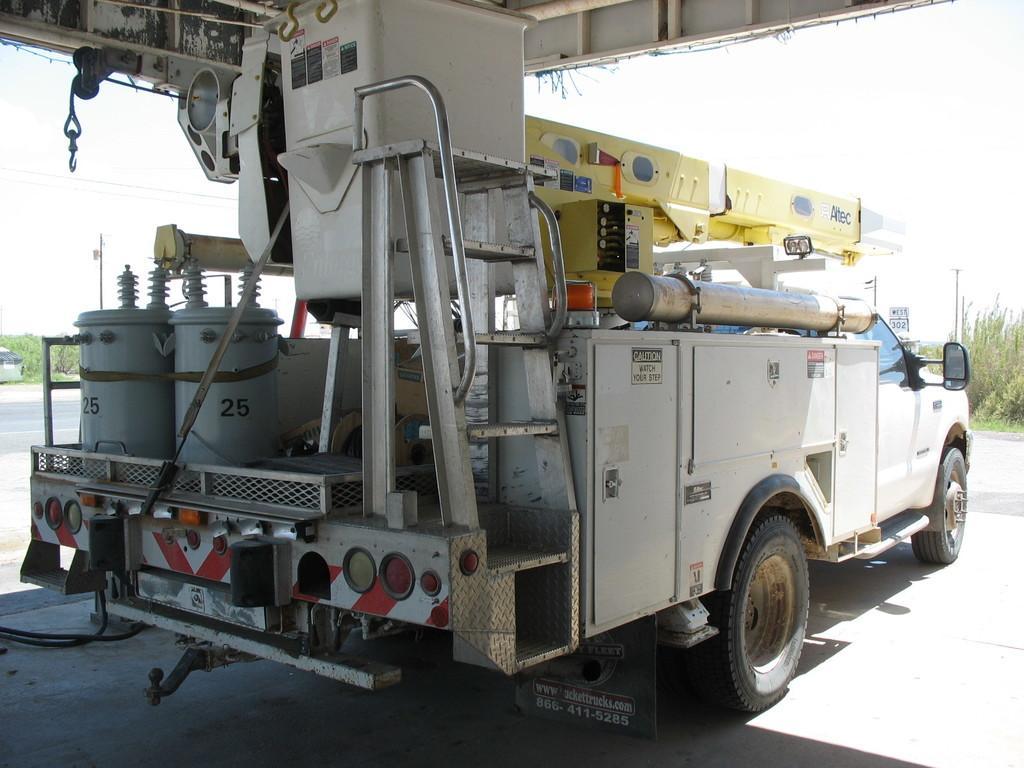How would you summarize this image in a sentence or two? This picture is clicked outside. In the center there is a vehicle containing some barrels and some machines and we can see the metal rod and some yellow color machines. In the background we can see the sky, plants and some other items. 